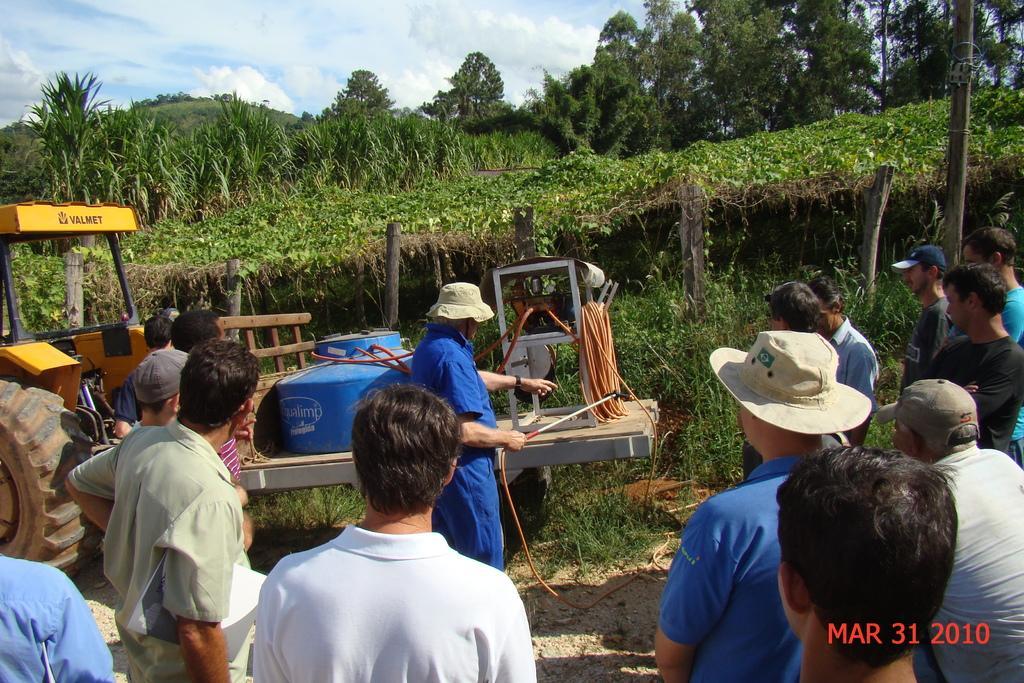Please provide a concise description of this image. Bottom of the image few people are standing. Top left side of the image there is a vehicle. Behind the vehicle there are some trees. Top of the image there are some clouds and sky. 